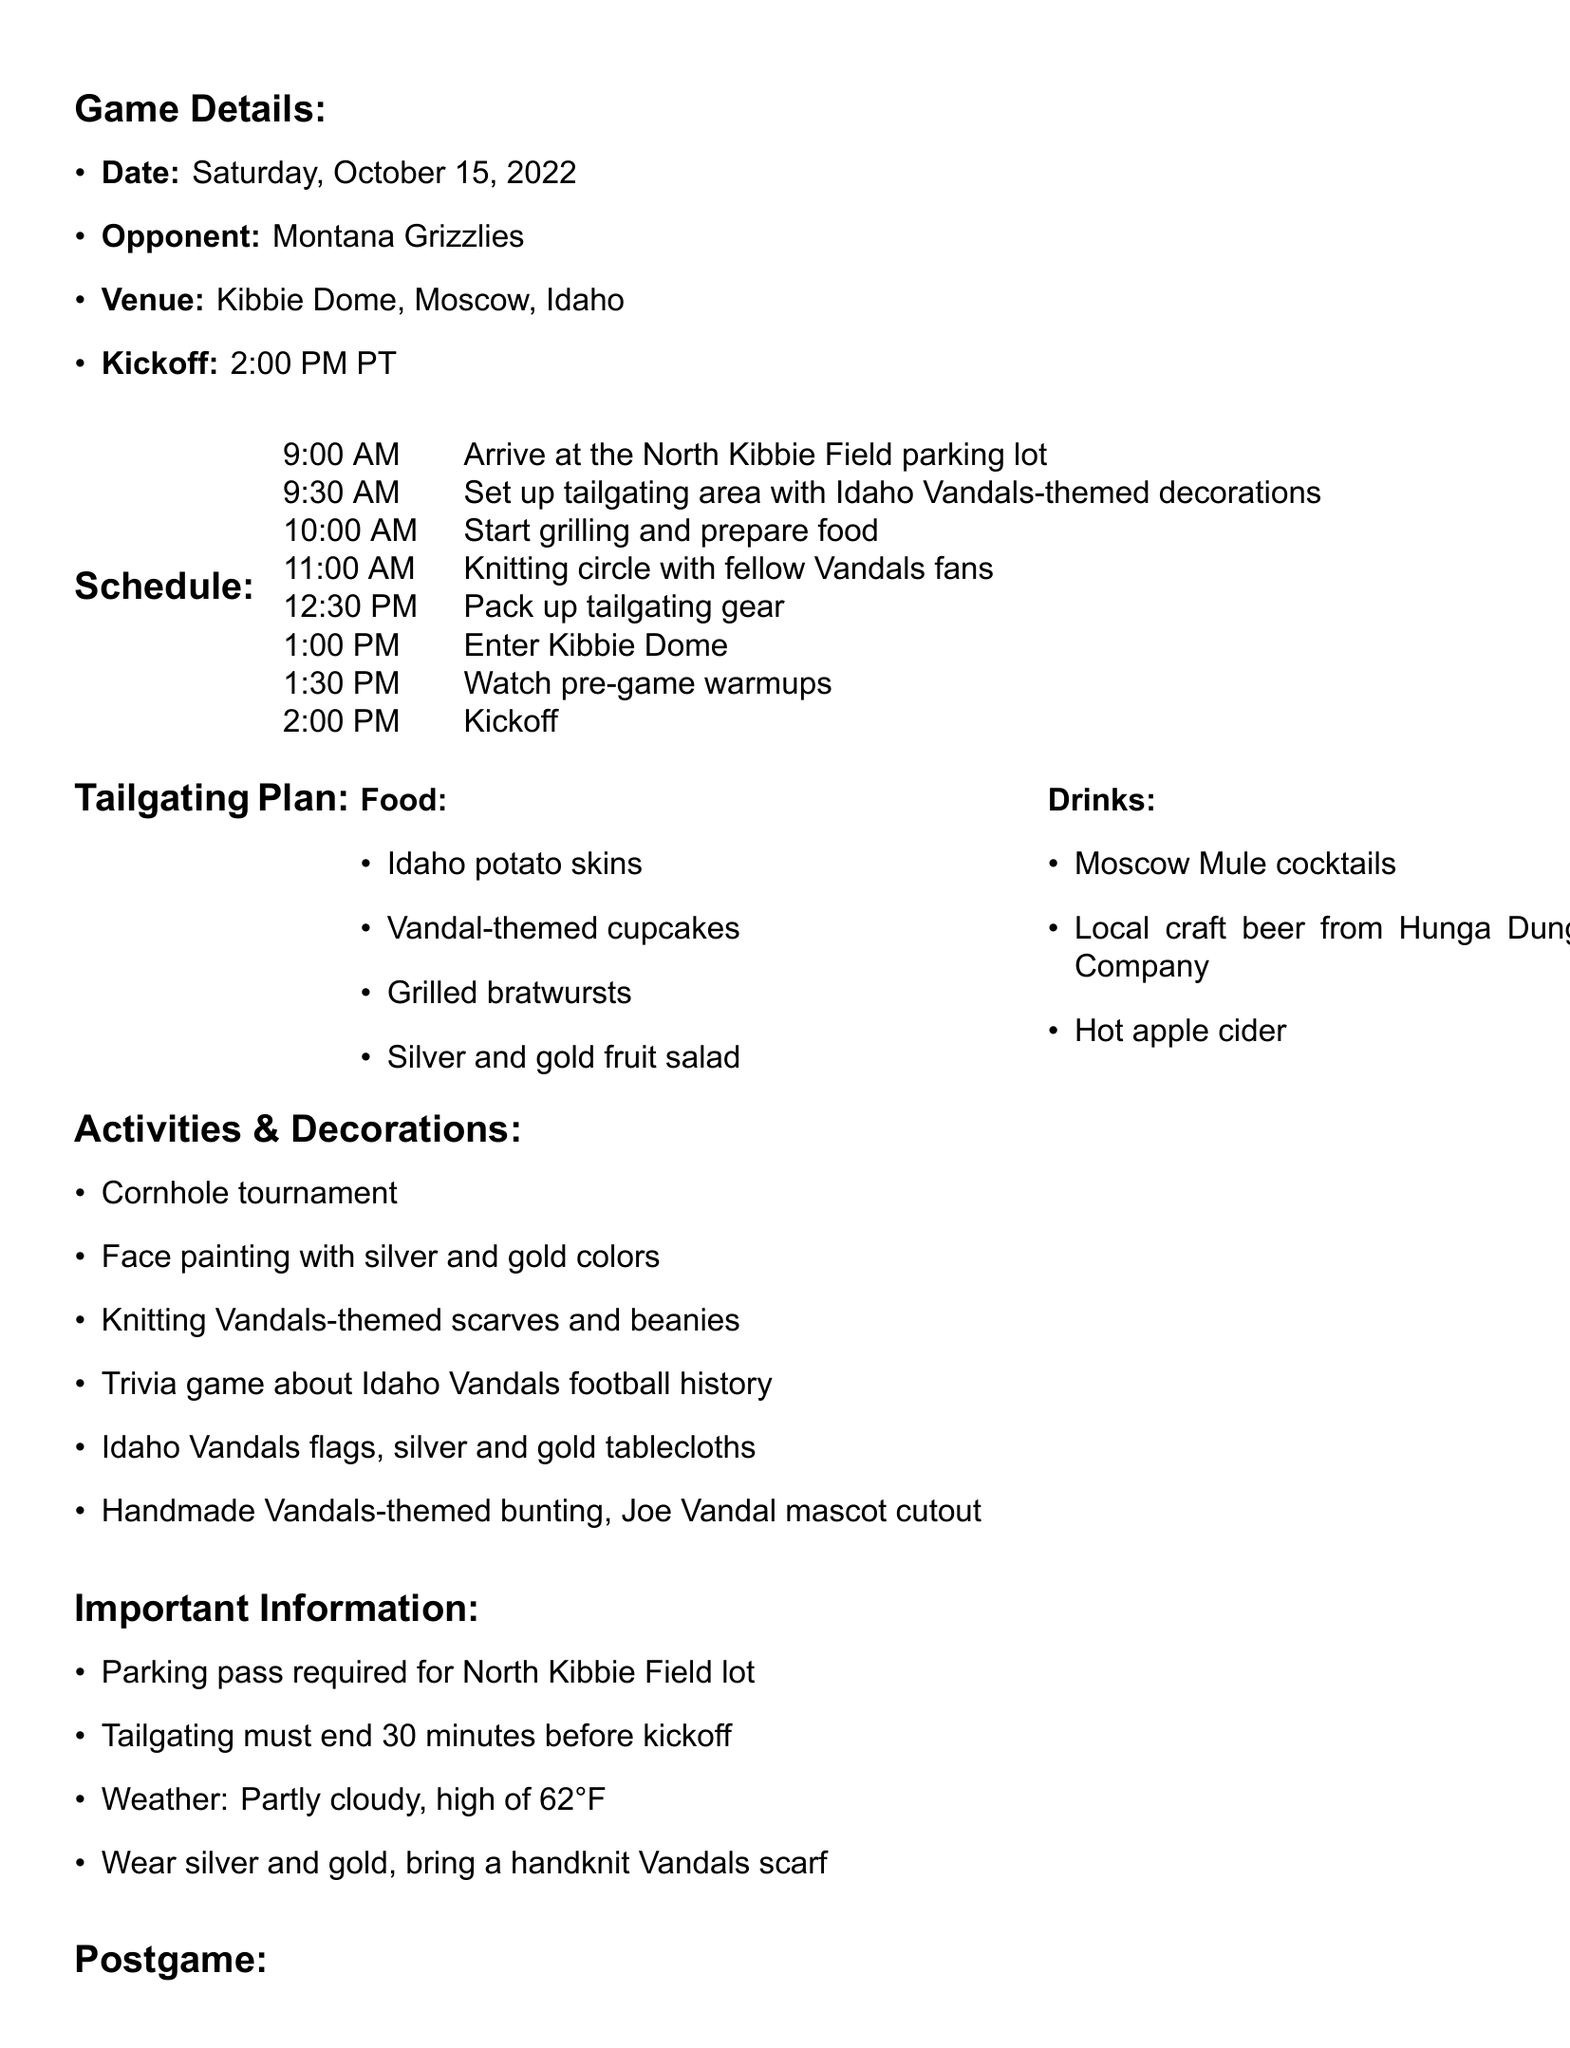What is the game day? The game day is specifically mentioned as "Saturday, October 15, 2022."
Answer: Saturday, October 15, 2022 Who is the opponent? The opponent for the game is explicitly stated in the document, which is "Montana Grizzlies."
Answer: Montana Grizzlies What time is kickoff? The document specifies the kickoff time as "2:00 PM PT."
Answer: 2:00 PM PT What activity is planned at 11:00 AM? The document lists the activity scheduled for 11:00 AM as a "Knitting circle with fellow Vandals fans."
Answer: Knitting circle with fellow Vandals fans What type of drinks will be served? The drinks section of the tailgating plan lists several options, including "Moscow Mule cocktails."
Answer: Moscow Mule cocktails What must tailgating end before? The tailgating rules in the document state that it must end "30 minutes before kickoff."
Answer: 30 minutes before kickoff What color should attendees wear? The important information section mentions that attendees should "Wear silver and gold."
Answer: silver and gold What project will start postgame? The document indicates that a new project will begin, which is to "Start a new Vandals-themed blanket project to commemorate the game."
Answer: Start a new Vandals-themed blanket project to commemorate the game 